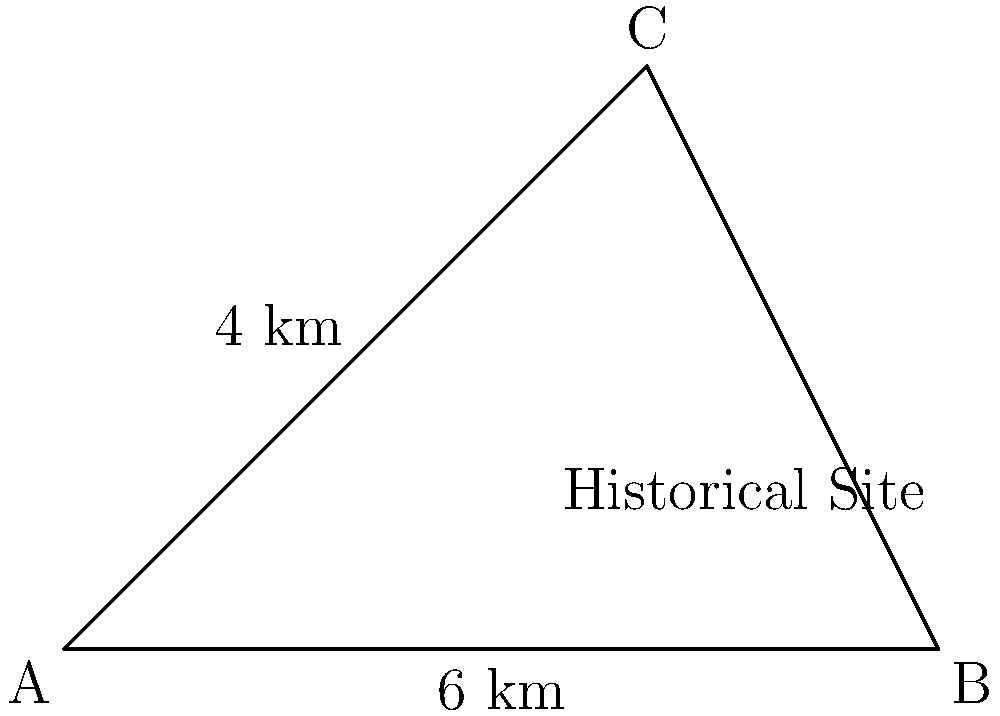As a local historian, you're documenting a triangular historical site. On your map, the site is represented by a triangle with sides of 6 km and 4 km meeting at a right angle. Using vector operations, calculate the area of this historical site in square kilometers. To calculate the area of the triangular historical site using vector operations, we'll follow these steps:

1) First, let's define our vectors. We can choose point A as our origin (0,0) and define two vectors:
   $\vec{v} = \overrightarrow{AB} = (6, 0)$ km
   $\vec{w} = \overrightarrow{AC} = (0, 4)$ km

2) The area of a parallelogram formed by two vectors is given by the magnitude of their cross product:
   Area = $|\vec{v} \times \vec{w}|$

3) For 2D vectors $\vec{v} = (v_x, v_y)$ and $\vec{w} = (w_x, w_y)$, the cross product is defined as:
   $\vec{v} \times \vec{w} = v_x w_y - v_y w_x$

4) Substituting our values:
   $\vec{v} \times \vec{w} = (6)(4) - (0)(0) = 24$

5) The magnitude of this scalar in 2D is simply its absolute value: 24

6) However, this gives us the area of a parallelogram. Since we want the area of a triangle, we need to divide by 2:
   Area of triangle = $\frac{|\vec{v} \times \vec{w}|}{2} = \frac{24}{2} = 12$

Therefore, the area of the historical site is 12 square kilometers.
Answer: 12 km² 